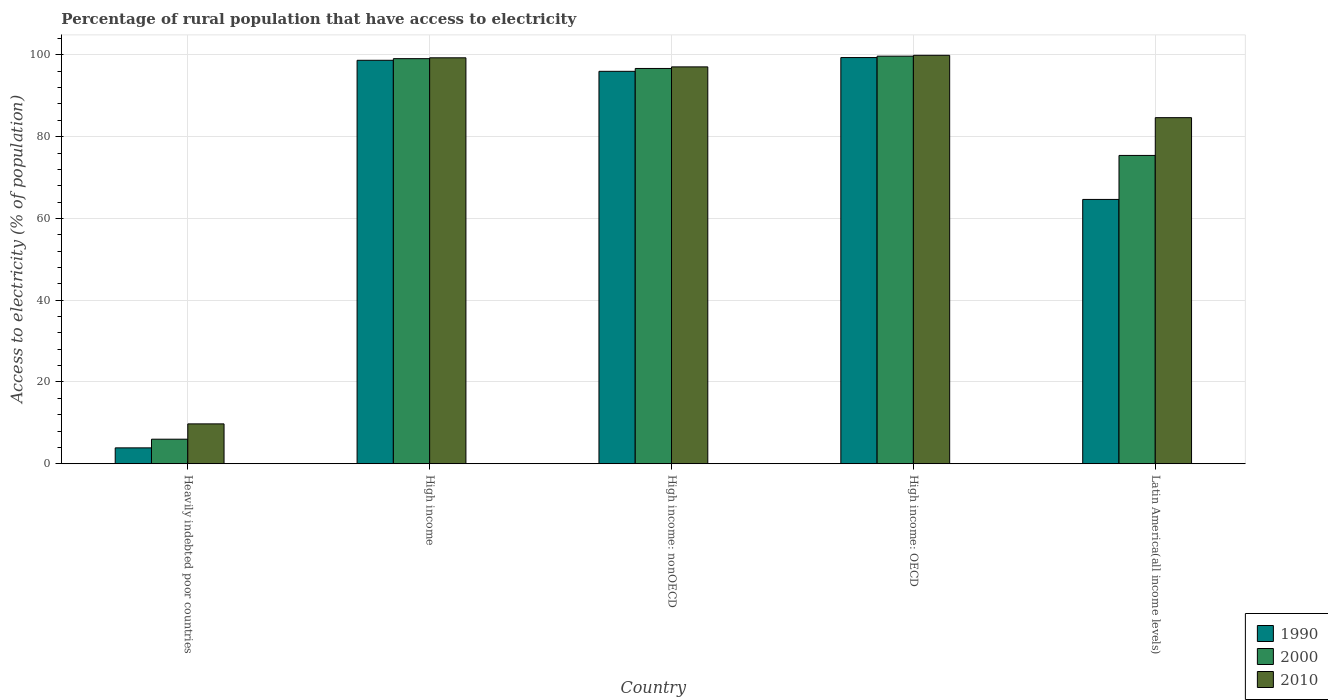How many groups of bars are there?
Your response must be concise. 5. Are the number of bars per tick equal to the number of legend labels?
Offer a terse response. Yes. What is the label of the 3rd group of bars from the left?
Your response must be concise. High income: nonOECD. What is the percentage of rural population that have access to electricity in 2000 in Latin America(all income levels)?
Your answer should be very brief. 75.4. Across all countries, what is the maximum percentage of rural population that have access to electricity in 1990?
Your answer should be compact. 99.34. Across all countries, what is the minimum percentage of rural population that have access to electricity in 2000?
Your response must be concise. 6. In which country was the percentage of rural population that have access to electricity in 1990 maximum?
Provide a short and direct response. High income: OECD. In which country was the percentage of rural population that have access to electricity in 2000 minimum?
Make the answer very short. Heavily indebted poor countries. What is the total percentage of rural population that have access to electricity in 2000 in the graph?
Your answer should be very brief. 376.85. What is the difference between the percentage of rural population that have access to electricity in 1990 in High income: OECD and that in Latin America(all income levels)?
Your answer should be very brief. 34.7. What is the difference between the percentage of rural population that have access to electricity in 2010 in High income and the percentage of rural population that have access to electricity in 2000 in High income: OECD?
Offer a terse response. -0.4. What is the average percentage of rural population that have access to electricity in 2010 per country?
Offer a terse response. 78.13. What is the difference between the percentage of rural population that have access to electricity of/in 1990 and percentage of rural population that have access to electricity of/in 2000 in High income: nonOECD?
Make the answer very short. -0.7. In how many countries, is the percentage of rural population that have access to electricity in 2000 greater than 44 %?
Your answer should be very brief. 4. What is the ratio of the percentage of rural population that have access to electricity in 2000 in High income: OECD to that in Latin America(all income levels)?
Keep it short and to the point. 1.32. Is the difference between the percentage of rural population that have access to electricity in 1990 in Heavily indebted poor countries and High income: nonOECD greater than the difference between the percentage of rural population that have access to electricity in 2000 in Heavily indebted poor countries and High income: nonOECD?
Your answer should be very brief. No. What is the difference between the highest and the second highest percentage of rural population that have access to electricity in 2000?
Offer a very short reply. -0.61. What is the difference between the highest and the lowest percentage of rural population that have access to electricity in 2000?
Provide a short and direct response. 93.68. Is the sum of the percentage of rural population that have access to electricity in 2010 in Heavily indebted poor countries and Latin America(all income levels) greater than the maximum percentage of rural population that have access to electricity in 1990 across all countries?
Your answer should be compact. No. What does the 2nd bar from the right in High income: OECD represents?
Offer a very short reply. 2000. Does the graph contain any zero values?
Provide a short and direct response. No. How many legend labels are there?
Offer a terse response. 3. How are the legend labels stacked?
Offer a very short reply. Vertical. What is the title of the graph?
Offer a terse response. Percentage of rural population that have access to electricity. What is the label or title of the X-axis?
Offer a terse response. Country. What is the label or title of the Y-axis?
Your answer should be very brief. Access to electricity (% of population). What is the Access to electricity (% of population) in 1990 in Heavily indebted poor countries?
Your response must be concise. 3.88. What is the Access to electricity (% of population) of 2000 in Heavily indebted poor countries?
Your answer should be compact. 6. What is the Access to electricity (% of population) of 2010 in Heavily indebted poor countries?
Your answer should be compact. 9.75. What is the Access to electricity (% of population) of 1990 in High income?
Provide a short and direct response. 98.67. What is the Access to electricity (% of population) of 2000 in High income?
Your response must be concise. 99.08. What is the Access to electricity (% of population) in 2010 in High income?
Your answer should be very brief. 99.28. What is the Access to electricity (% of population) of 1990 in High income: nonOECD?
Give a very brief answer. 95.98. What is the Access to electricity (% of population) in 2000 in High income: nonOECD?
Provide a succinct answer. 96.68. What is the Access to electricity (% of population) in 2010 in High income: nonOECD?
Make the answer very short. 97.06. What is the Access to electricity (% of population) of 1990 in High income: OECD?
Keep it short and to the point. 99.34. What is the Access to electricity (% of population) of 2000 in High income: OECD?
Your response must be concise. 99.68. What is the Access to electricity (% of population) in 2010 in High income: OECD?
Provide a short and direct response. 99.9. What is the Access to electricity (% of population) in 1990 in Latin America(all income levels)?
Ensure brevity in your answer.  64.64. What is the Access to electricity (% of population) in 2000 in Latin America(all income levels)?
Make the answer very short. 75.4. What is the Access to electricity (% of population) in 2010 in Latin America(all income levels)?
Keep it short and to the point. 84.64. Across all countries, what is the maximum Access to electricity (% of population) in 1990?
Keep it short and to the point. 99.34. Across all countries, what is the maximum Access to electricity (% of population) in 2000?
Your answer should be compact. 99.68. Across all countries, what is the maximum Access to electricity (% of population) in 2010?
Keep it short and to the point. 99.9. Across all countries, what is the minimum Access to electricity (% of population) of 1990?
Keep it short and to the point. 3.88. Across all countries, what is the minimum Access to electricity (% of population) of 2000?
Ensure brevity in your answer.  6. Across all countries, what is the minimum Access to electricity (% of population) in 2010?
Keep it short and to the point. 9.75. What is the total Access to electricity (% of population) in 1990 in the graph?
Keep it short and to the point. 362.52. What is the total Access to electricity (% of population) in 2000 in the graph?
Your answer should be very brief. 376.85. What is the total Access to electricity (% of population) of 2010 in the graph?
Your answer should be compact. 390.63. What is the difference between the Access to electricity (% of population) in 1990 in Heavily indebted poor countries and that in High income?
Give a very brief answer. -94.79. What is the difference between the Access to electricity (% of population) of 2000 in Heavily indebted poor countries and that in High income?
Keep it short and to the point. -93.07. What is the difference between the Access to electricity (% of population) in 2010 in Heavily indebted poor countries and that in High income?
Your response must be concise. -89.54. What is the difference between the Access to electricity (% of population) of 1990 in Heavily indebted poor countries and that in High income: nonOECD?
Provide a short and direct response. -92.09. What is the difference between the Access to electricity (% of population) of 2000 in Heavily indebted poor countries and that in High income: nonOECD?
Offer a very short reply. -90.67. What is the difference between the Access to electricity (% of population) of 2010 in Heavily indebted poor countries and that in High income: nonOECD?
Offer a terse response. -87.32. What is the difference between the Access to electricity (% of population) in 1990 in Heavily indebted poor countries and that in High income: OECD?
Offer a very short reply. -95.46. What is the difference between the Access to electricity (% of population) in 2000 in Heavily indebted poor countries and that in High income: OECD?
Give a very brief answer. -93.68. What is the difference between the Access to electricity (% of population) of 2010 in Heavily indebted poor countries and that in High income: OECD?
Make the answer very short. -90.15. What is the difference between the Access to electricity (% of population) of 1990 in Heavily indebted poor countries and that in Latin America(all income levels)?
Your response must be concise. -60.76. What is the difference between the Access to electricity (% of population) of 2000 in Heavily indebted poor countries and that in Latin America(all income levels)?
Your response must be concise. -69.4. What is the difference between the Access to electricity (% of population) of 2010 in Heavily indebted poor countries and that in Latin America(all income levels)?
Make the answer very short. -74.9. What is the difference between the Access to electricity (% of population) of 1990 in High income and that in High income: nonOECD?
Your response must be concise. 2.7. What is the difference between the Access to electricity (% of population) of 2000 in High income and that in High income: nonOECD?
Give a very brief answer. 2.4. What is the difference between the Access to electricity (% of population) of 2010 in High income and that in High income: nonOECD?
Give a very brief answer. 2.22. What is the difference between the Access to electricity (% of population) in 1990 in High income and that in High income: OECD?
Ensure brevity in your answer.  -0.67. What is the difference between the Access to electricity (% of population) in 2000 in High income and that in High income: OECD?
Give a very brief answer. -0.61. What is the difference between the Access to electricity (% of population) in 2010 in High income and that in High income: OECD?
Offer a very short reply. -0.61. What is the difference between the Access to electricity (% of population) in 1990 in High income and that in Latin America(all income levels)?
Ensure brevity in your answer.  34.03. What is the difference between the Access to electricity (% of population) of 2000 in High income and that in Latin America(all income levels)?
Make the answer very short. 23.67. What is the difference between the Access to electricity (% of population) of 2010 in High income and that in Latin America(all income levels)?
Keep it short and to the point. 14.64. What is the difference between the Access to electricity (% of population) in 1990 in High income: nonOECD and that in High income: OECD?
Provide a succinct answer. -3.37. What is the difference between the Access to electricity (% of population) in 2000 in High income: nonOECD and that in High income: OECD?
Offer a very short reply. -3.01. What is the difference between the Access to electricity (% of population) of 2010 in High income: nonOECD and that in High income: OECD?
Ensure brevity in your answer.  -2.83. What is the difference between the Access to electricity (% of population) in 1990 in High income: nonOECD and that in Latin America(all income levels)?
Your answer should be compact. 31.33. What is the difference between the Access to electricity (% of population) in 2000 in High income: nonOECD and that in Latin America(all income levels)?
Ensure brevity in your answer.  21.27. What is the difference between the Access to electricity (% of population) of 2010 in High income: nonOECD and that in Latin America(all income levels)?
Offer a very short reply. 12.42. What is the difference between the Access to electricity (% of population) in 1990 in High income: OECD and that in Latin America(all income levels)?
Keep it short and to the point. 34.7. What is the difference between the Access to electricity (% of population) in 2000 in High income: OECD and that in Latin America(all income levels)?
Your response must be concise. 24.28. What is the difference between the Access to electricity (% of population) of 2010 in High income: OECD and that in Latin America(all income levels)?
Provide a succinct answer. 15.25. What is the difference between the Access to electricity (% of population) of 1990 in Heavily indebted poor countries and the Access to electricity (% of population) of 2000 in High income?
Keep it short and to the point. -95.19. What is the difference between the Access to electricity (% of population) of 1990 in Heavily indebted poor countries and the Access to electricity (% of population) of 2010 in High income?
Offer a very short reply. -95.4. What is the difference between the Access to electricity (% of population) of 2000 in Heavily indebted poor countries and the Access to electricity (% of population) of 2010 in High income?
Give a very brief answer. -93.28. What is the difference between the Access to electricity (% of population) of 1990 in Heavily indebted poor countries and the Access to electricity (% of population) of 2000 in High income: nonOECD?
Provide a short and direct response. -92.79. What is the difference between the Access to electricity (% of population) of 1990 in Heavily indebted poor countries and the Access to electricity (% of population) of 2010 in High income: nonOECD?
Provide a succinct answer. -93.18. What is the difference between the Access to electricity (% of population) in 2000 in Heavily indebted poor countries and the Access to electricity (% of population) in 2010 in High income: nonOECD?
Ensure brevity in your answer.  -91.06. What is the difference between the Access to electricity (% of population) of 1990 in Heavily indebted poor countries and the Access to electricity (% of population) of 2000 in High income: OECD?
Keep it short and to the point. -95.8. What is the difference between the Access to electricity (% of population) in 1990 in Heavily indebted poor countries and the Access to electricity (% of population) in 2010 in High income: OECD?
Offer a very short reply. -96.01. What is the difference between the Access to electricity (% of population) of 2000 in Heavily indebted poor countries and the Access to electricity (% of population) of 2010 in High income: OECD?
Offer a terse response. -93.89. What is the difference between the Access to electricity (% of population) in 1990 in Heavily indebted poor countries and the Access to electricity (% of population) in 2000 in Latin America(all income levels)?
Your answer should be very brief. -71.52. What is the difference between the Access to electricity (% of population) in 1990 in Heavily indebted poor countries and the Access to electricity (% of population) in 2010 in Latin America(all income levels)?
Your answer should be compact. -80.76. What is the difference between the Access to electricity (% of population) in 2000 in Heavily indebted poor countries and the Access to electricity (% of population) in 2010 in Latin America(all income levels)?
Offer a terse response. -78.64. What is the difference between the Access to electricity (% of population) of 1990 in High income and the Access to electricity (% of population) of 2000 in High income: nonOECD?
Make the answer very short. 2. What is the difference between the Access to electricity (% of population) of 1990 in High income and the Access to electricity (% of population) of 2010 in High income: nonOECD?
Your response must be concise. 1.61. What is the difference between the Access to electricity (% of population) in 2000 in High income and the Access to electricity (% of population) in 2010 in High income: nonOECD?
Give a very brief answer. 2.01. What is the difference between the Access to electricity (% of population) of 1990 in High income and the Access to electricity (% of population) of 2000 in High income: OECD?
Ensure brevity in your answer.  -1.01. What is the difference between the Access to electricity (% of population) of 1990 in High income and the Access to electricity (% of population) of 2010 in High income: OECD?
Give a very brief answer. -1.22. What is the difference between the Access to electricity (% of population) in 2000 in High income and the Access to electricity (% of population) in 2010 in High income: OECD?
Your answer should be compact. -0.82. What is the difference between the Access to electricity (% of population) of 1990 in High income and the Access to electricity (% of population) of 2000 in Latin America(all income levels)?
Offer a terse response. 23.27. What is the difference between the Access to electricity (% of population) of 1990 in High income and the Access to electricity (% of population) of 2010 in Latin America(all income levels)?
Your answer should be very brief. 14.03. What is the difference between the Access to electricity (% of population) of 2000 in High income and the Access to electricity (% of population) of 2010 in Latin America(all income levels)?
Offer a very short reply. 14.43. What is the difference between the Access to electricity (% of population) of 1990 in High income: nonOECD and the Access to electricity (% of population) of 2000 in High income: OECD?
Make the answer very short. -3.71. What is the difference between the Access to electricity (% of population) in 1990 in High income: nonOECD and the Access to electricity (% of population) in 2010 in High income: OECD?
Your answer should be very brief. -3.92. What is the difference between the Access to electricity (% of population) of 2000 in High income: nonOECD and the Access to electricity (% of population) of 2010 in High income: OECD?
Provide a succinct answer. -3.22. What is the difference between the Access to electricity (% of population) in 1990 in High income: nonOECD and the Access to electricity (% of population) in 2000 in Latin America(all income levels)?
Ensure brevity in your answer.  20.57. What is the difference between the Access to electricity (% of population) in 1990 in High income: nonOECD and the Access to electricity (% of population) in 2010 in Latin America(all income levels)?
Provide a succinct answer. 11.34. What is the difference between the Access to electricity (% of population) in 2000 in High income: nonOECD and the Access to electricity (% of population) in 2010 in Latin America(all income levels)?
Your answer should be compact. 12.03. What is the difference between the Access to electricity (% of population) of 1990 in High income: OECD and the Access to electricity (% of population) of 2000 in Latin America(all income levels)?
Keep it short and to the point. 23.94. What is the difference between the Access to electricity (% of population) of 1990 in High income: OECD and the Access to electricity (% of population) of 2010 in Latin America(all income levels)?
Your answer should be compact. 14.7. What is the difference between the Access to electricity (% of population) of 2000 in High income: OECD and the Access to electricity (% of population) of 2010 in Latin America(all income levels)?
Provide a short and direct response. 15.04. What is the average Access to electricity (% of population) in 1990 per country?
Offer a terse response. 72.5. What is the average Access to electricity (% of population) in 2000 per country?
Keep it short and to the point. 75.37. What is the average Access to electricity (% of population) of 2010 per country?
Your answer should be very brief. 78.13. What is the difference between the Access to electricity (% of population) in 1990 and Access to electricity (% of population) in 2000 in Heavily indebted poor countries?
Your answer should be very brief. -2.12. What is the difference between the Access to electricity (% of population) of 1990 and Access to electricity (% of population) of 2010 in Heavily indebted poor countries?
Your response must be concise. -5.86. What is the difference between the Access to electricity (% of population) in 2000 and Access to electricity (% of population) in 2010 in Heavily indebted poor countries?
Your answer should be very brief. -3.74. What is the difference between the Access to electricity (% of population) of 1990 and Access to electricity (% of population) of 2000 in High income?
Your answer should be very brief. -0.4. What is the difference between the Access to electricity (% of population) of 1990 and Access to electricity (% of population) of 2010 in High income?
Your answer should be compact. -0.61. What is the difference between the Access to electricity (% of population) of 2000 and Access to electricity (% of population) of 2010 in High income?
Your response must be concise. -0.21. What is the difference between the Access to electricity (% of population) of 1990 and Access to electricity (% of population) of 2000 in High income: nonOECD?
Make the answer very short. -0.7. What is the difference between the Access to electricity (% of population) of 1990 and Access to electricity (% of population) of 2010 in High income: nonOECD?
Ensure brevity in your answer.  -1.08. What is the difference between the Access to electricity (% of population) of 2000 and Access to electricity (% of population) of 2010 in High income: nonOECD?
Give a very brief answer. -0.39. What is the difference between the Access to electricity (% of population) of 1990 and Access to electricity (% of population) of 2000 in High income: OECD?
Your answer should be compact. -0.34. What is the difference between the Access to electricity (% of population) in 1990 and Access to electricity (% of population) in 2010 in High income: OECD?
Your answer should be compact. -0.55. What is the difference between the Access to electricity (% of population) of 2000 and Access to electricity (% of population) of 2010 in High income: OECD?
Offer a very short reply. -0.21. What is the difference between the Access to electricity (% of population) of 1990 and Access to electricity (% of population) of 2000 in Latin America(all income levels)?
Keep it short and to the point. -10.76. What is the difference between the Access to electricity (% of population) of 1990 and Access to electricity (% of population) of 2010 in Latin America(all income levels)?
Your response must be concise. -20. What is the difference between the Access to electricity (% of population) of 2000 and Access to electricity (% of population) of 2010 in Latin America(all income levels)?
Provide a short and direct response. -9.24. What is the ratio of the Access to electricity (% of population) in 1990 in Heavily indebted poor countries to that in High income?
Your response must be concise. 0.04. What is the ratio of the Access to electricity (% of population) of 2000 in Heavily indebted poor countries to that in High income?
Provide a short and direct response. 0.06. What is the ratio of the Access to electricity (% of population) of 2010 in Heavily indebted poor countries to that in High income?
Offer a terse response. 0.1. What is the ratio of the Access to electricity (% of population) of 1990 in Heavily indebted poor countries to that in High income: nonOECD?
Give a very brief answer. 0.04. What is the ratio of the Access to electricity (% of population) in 2000 in Heavily indebted poor countries to that in High income: nonOECD?
Your response must be concise. 0.06. What is the ratio of the Access to electricity (% of population) of 2010 in Heavily indebted poor countries to that in High income: nonOECD?
Give a very brief answer. 0.1. What is the ratio of the Access to electricity (% of population) of 1990 in Heavily indebted poor countries to that in High income: OECD?
Offer a very short reply. 0.04. What is the ratio of the Access to electricity (% of population) of 2000 in Heavily indebted poor countries to that in High income: OECD?
Your response must be concise. 0.06. What is the ratio of the Access to electricity (% of population) of 2010 in Heavily indebted poor countries to that in High income: OECD?
Your answer should be compact. 0.1. What is the ratio of the Access to electricity (% of population) of 1990 in Heavily indebted poor countries to that in Latin America(all income levels)?
Provide a succinct answer. 0.06. What is the ratio of the Access to electricity (% of population) of 2000 in Heavily indebted poor countries to that in Latin America(all income levels)?
Give a very brief answer. 0.08. What is the ratio of the Access to electricity (% of population) in 2010 in Heavily indebted poor countries to that in Latin America(all income levels)?
Provide a succinct answer. 0.12. What is the ratio of the Access to electricity (% of population) in 1990 in High income to that in High income: nonOECD?
Give a very brief answer. 1.03. What is the ratio of the Access to electricity (% of population) in 2000 in High income to that in High income: nonOECD?
Your response must be concise. 1.02. What is the ratio of the Access to electricity (% of population) in 2010 in High income to that in High income: nonOECD?
Make the answer very short. 1.02. What is the ratio of the Access to electricity (% of population) of 2010 in High income to that in High income: OECD?
Your answer should be very brief. 0.99. What is the ratio of the Access to electricity (% of population) of 1990 in High income to that in Latin America(all income levels)?
Keep it short and to the point. 1.53. What is the ratio of the Access to electricity (% of population) in 2000 in High income to that in Latin America(all income levels)?
Your answer should be compact. 1.31. What is the ratio of the Access to electricity (% of population) of 2010 in High income to that in Latin America(all income levels)?
Your response must be concise. 1.17. What is the ratio of the Access to electricity (% of population) in 1990 in High income: nonOECD to that in High income: OECD?
Keep it short and to the point. 0.97. What is the ratio of the Access to electricity (% of population) in 2000 in High income: nonOECD to that in High income: OECD?
Give a very brief answer. 0.97. What is the ratio of the Access to electricity (% of population) in 2010 in High income: nonOECD to that in High income: OECD?
Your answer should be very brief. 0.97. What is the ratio of the Access to electricity (% of population) in 1990 in High income: nonOECD to that in Latin America(all income levels)?
Give a very brief answer. 1.48. What is the ratio of the Access to electricity (% of population) of 2000 in High income: nonOECD to that in Latin America(all income levels)?
Provide a succinct answer. 1.28. What is the ratio of the Access to electricity (% of population) in 2010 in High income: nonOECD to that in Latin America(all income levels)?
Give a very brief answer. 1.15. What is the ratio of the Access to electricity (% of population) in 1990 in High income: OECD to that in Latin America(all income levels)?
Your answer should be very brief. 1.54. What is the ratio of the Access to electricity (% of population) in 2000 in High income: OECD to that in Latin America(all income levels)?
Ensure brevity in your answer.  1.32. What is the ratio of the Access to electricity (% of population) of 2010 in High income: OECD to that in Latin America(all income levels)?
Provide a short and direct response. 1.18. What is the difference between the highest and the second highest Access to electricity (% of population) of 1990?
Ensure brevity in your answer.  0.67. What is the difference between the highest and the second highest Access to electricity (% of population) in 2000?
Ensure brevity in your answer.  0.61. What is the difference between the highest and the second highest Access to electricity (% of population) of 2010?
Provide a short and direct response. 0.61. What is the difference between the highest and the lowest Access to electricity (% of population) in 1990?
Give a very brief answer. 95.46. What is the difference between the highest and the lowest Access to electricity (% of population) in 2000?
Provide a short and direct response. 93.68. What is the difference between the highest and the lowest Access to electricity (% of population) of 2010?
Provide a short and direct response. 90.15. 